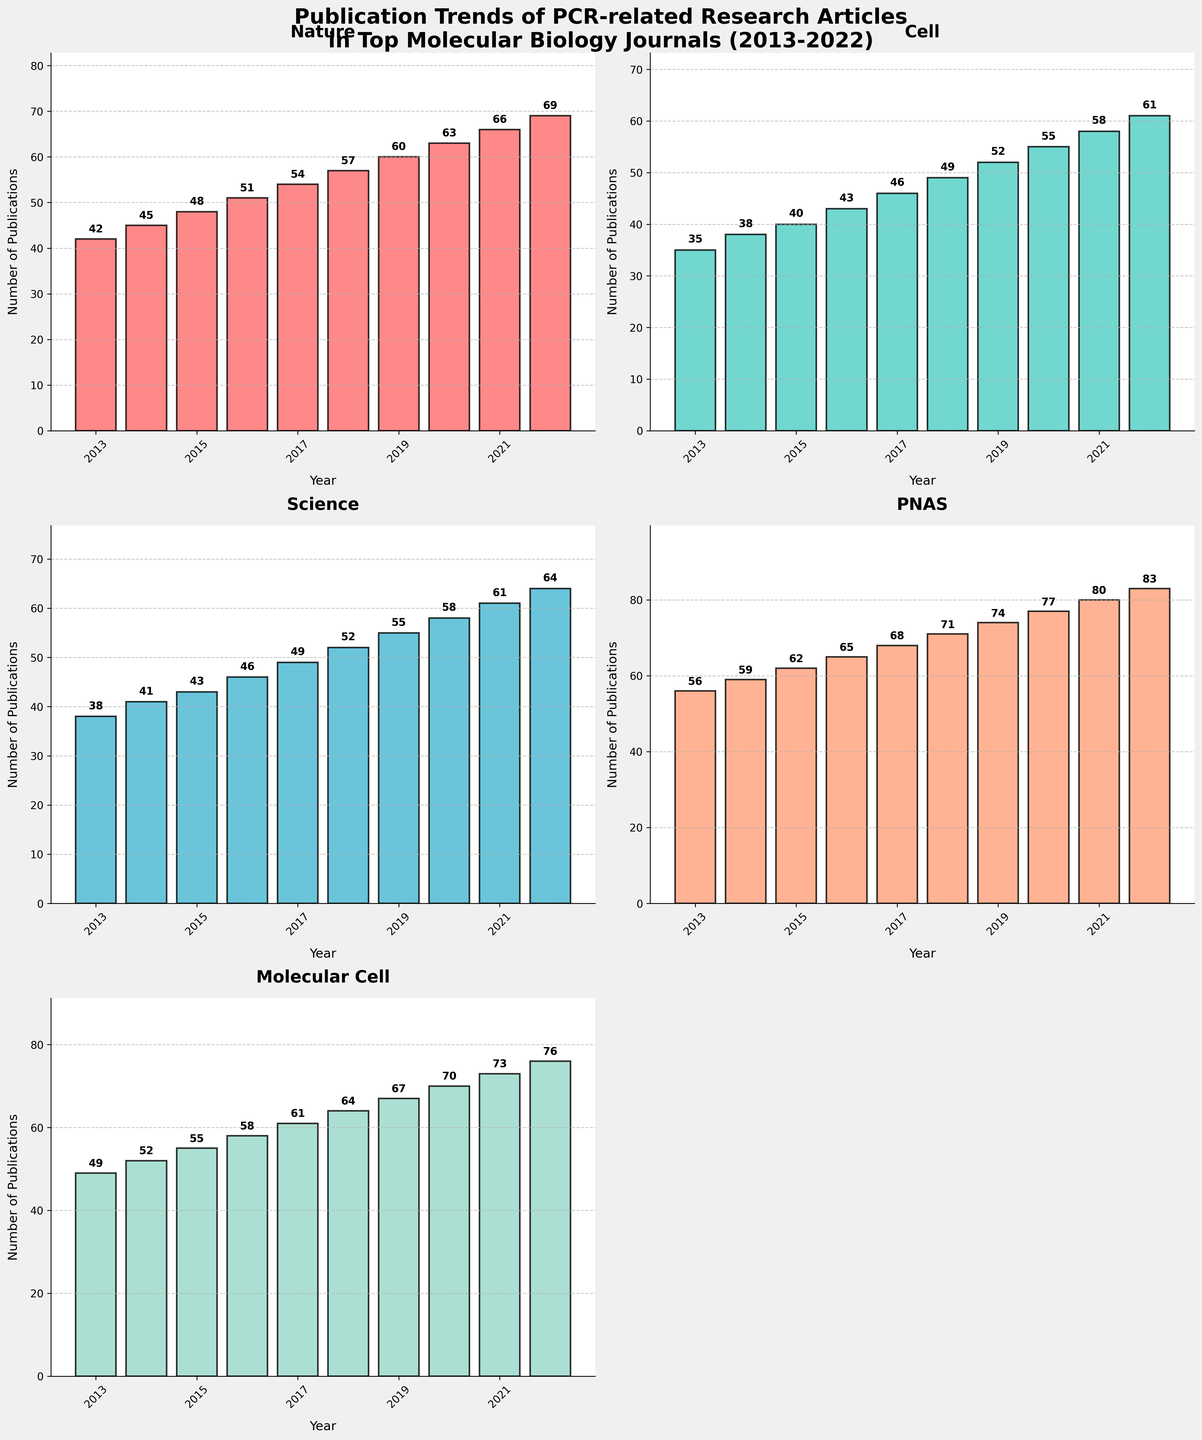what is the title of the figure? The title of the figure is displayed prominently at the top of the chart. It reads "Publication Trends of PCR-related Research Articles in Top Molecular Biology Journals (2013-2022)."
Answer: "Publication Trends of PCR-related Research Articles in Top Molecular Biology Journals (2013-2022)" How many journals are represented in the figure? The figure has subplots for each journal and counts 5 journals: "Nature," "Cell," "Science," "PNAS," and "Molecular Cell."
Answer: 5 Which journal had the highest number of PCR-related publications in 2022? In the subplot for each journal, we see the numbers on top of each bar for the year 2022. The highest value across all plots is 83 for "PNAS."
Answer: PNAS What's the difference in the number of PCR-related publications between "Nature" and "Cell" in 2020? In 2020, the bar for "Nature" shows 63, and for "Cell," it shows 55. Subtracting the number for "Cell" from "Nature," we get 63 - 55.
Answer: 8 Between which years did "Molecular Cell" have the most significant increase in PCR-related publications? By looking at the heights of the bars and their values for "Molecular Cell," the most significant increase occurred between 2013 (49) and 2022 (76). The difference is the largest increase.
Answer: 2013 and 2022 Which journal had a consistent annual increase in the number of PCR-related publications? Examining all the subplots, we see that the number of publications increases every year for "PNAS" without any decrease or plateau.
Answer: PNAS How does the trend of PCR-related publications in "Science" compare between 2017 and 2019? Looking at the subplot for "Science," we see an increase from 49 in 2017 to 55 in 2019. The trend shows an upward movement.
Answer: Increasing What's the average number of PCR-related publications in "Nature" over the decade? Adding up the values for "Nature" (42, 45, 48, 51, 54, 57, 60, 63, 66, 69) and then dividing by 10, the calculation is (42+45+48+51+54+57+60+63+66+69)/10.
Answer: 55.5 How many data points are shown in each subplot? Each subplot shows the number of publications for each year from 2013 to 2022, so there are 10 data points in each subplot.
Answer: 10 